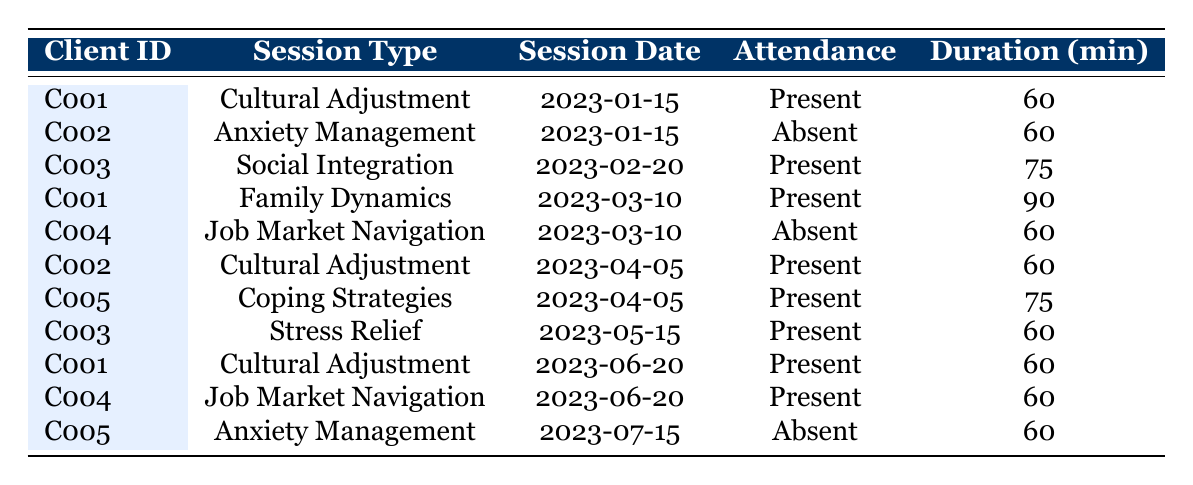What is the attendance status of client C002 for the session on 2023-01-15? In the table, we look for the row where the client ID is C002 and the session date is 2023-01-15. We find that the attendance status for client C002 on this date is marked as "Absent."
Answer: Absent How many sessions did client C001 attend in total? We check each row for client C001. The rows show that client C001 attended sessions on 2023-01-15, 2023-03-10, 2023-06-20, which totals to 3 sessions attended.
Answer: 3 What are the total duration in minutes of all sessions attended by client C005? We find the rows for client C005, which shows attendance on 2023-04-05 (75 minutes) and absence on 2023-07-15. Since there is only one attended session, we can confirm the total duration is 75 minutes.
Answer: 75 Did client C003 attend the session on 2023-05-15? The table shows that client C003 did attend the session on 2023-05-15, so the answer is yes.
Answer: Yes Which session type had the highest attendance duration for client C001? Reviewing the data for client C001:
- Cultural Adjustment on 2023-01-15: 60 minutes
- Family Dynamics on 2023-03-10: 90 minutes
- Cultural Adjustment on 2023-06-20: 60 minutes
The longest duration is 90 minutes for the Family Dynamics session.
Answer: Family Dynamics How many clients were present in the session type "Cultural Adjustment"? There are two instances of "Cultural Adjustment" sessions in the table: one attended by C001 on 2023-01-15 (60 minutes) and another by C002 on 2023-04-05 (60 minutes). Thus, there were 2 clients present in total.
Answer: 2 What was the attendance status of client C004 across all sessions? Checking the table, client C004 was marked as "Absent" for the session on 2023-03-10 and "Present" for the session on 2023-06-20, revealing an attendance status of one Absent and one Present.
Answer: Absent and Present Which session type did client C005 miss? Looking at client C005's entries, we see that on 2023-07-15, they were marked "Absent" for the session type "Anxiety Management."
Answer: Anxiety Management Which client had the most present statuses in the sessions attended? Analyzing attendance, C001 has attended three times (with present statuses), while other clients range from one to two present statuses. Therefore, client C001 stands out.
Answer: C001 